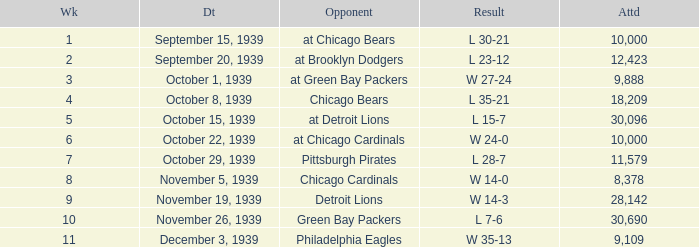Which Week has a Result of w 24-0, and an Attendance smaller than 10,000? None. 